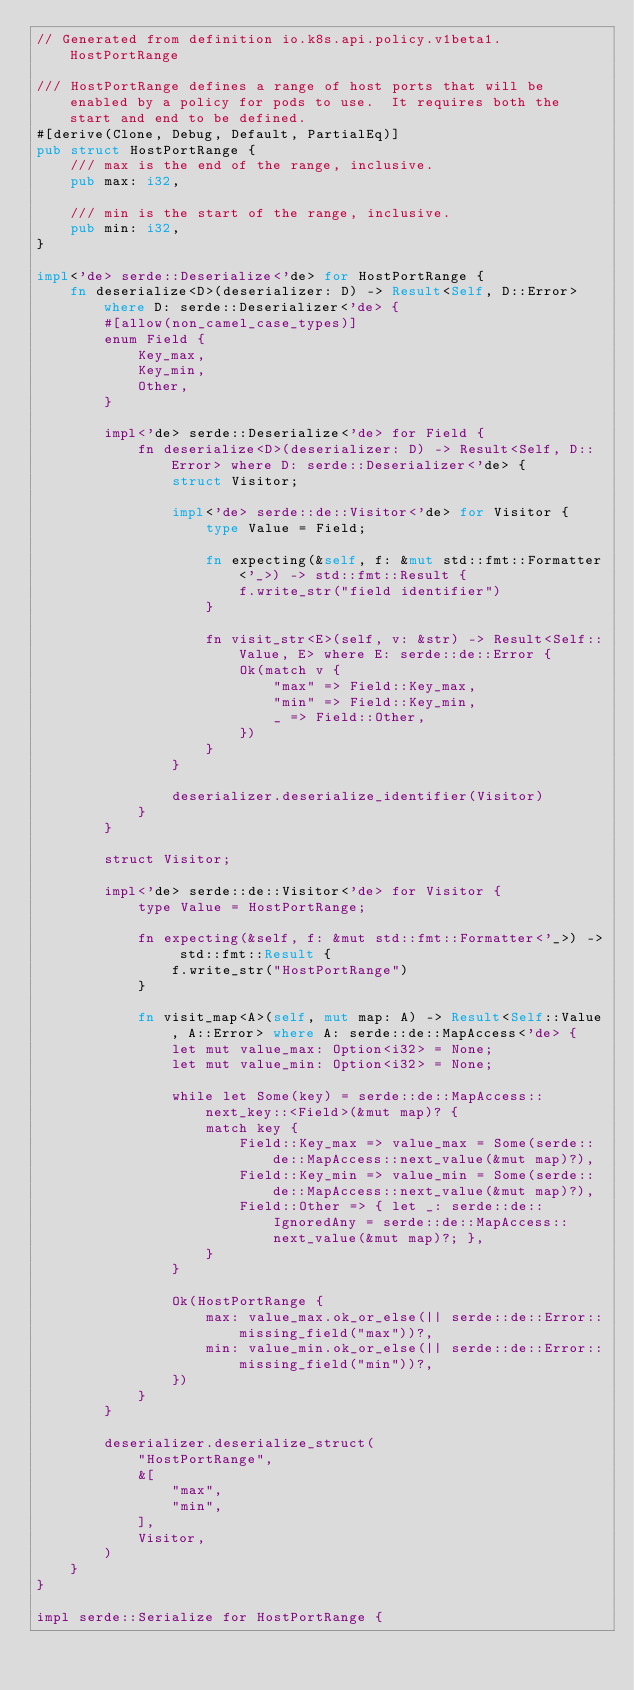Convert code to text. <code><loc_0><loc_0><loc_500><loc_500><_Rust_>// Generated from definition io.k8s.api.policy.v1beta1.HostPortRange

/// HostPortRange defines a range of host ports that will be enabled by a policy for pods to use.  It requires both the start and end to be defined.
#[derive(Clone, Debug, Default, PartialEq)]
pub struct HostPortRange {
    /// max is the end of the range, inclusive.
    pub max: i32,

    /// min is the start of the range, inclusive.
    pub min: i32,
}

impl<'de> serde::Deserialize<'de> for HostPortRange {
    fn deserialize<D>(deserializer: D) -> Result<Self, D::Error> where D: serde::Deserializer<'de> {
        #[allow(non_camel_case_types)]
        enum Field {
            Key_max,
            Key_min,
            Other,
        }

        impl<'de> serde::Deserialize<'de> for Field {
            fn deserialize<D>(deserializer: D) -> Result<Self, D::Error> where D: serde::Deserializer<'de> {
                struct Visitor;

                impl<'de> serde::de::Visitor<'de> for Visitor {
                    type Value = Field;

                    fn expecting(&self, f: &mut std::fmt::Formatter<'_>) -> std::fmt::Result {
                        f.write_str("field identifier")
                    }

                    fn visit_str<E>(self, v: &str) -> Result<Self::Value, E> where E: serde::de::Error {
                        Ok(match v {
                            "max" => Field::Key_max,
                            "min" => Field::Key_min,
                            _ => Field::Other,
                        })
                    }
                }

                deserializer.deserialize_identifier(Visitor)
            }
        }

        struct Visitor;

        impl<'de> serde::de::Visitor<'de> for Visitor {
            type Value = HostPortRange;

            fn expecting(&self, f: &mut std::fmt::Formatter<'_>) -> std::fmt::Result {
                f.write_str("HostPortRange")
            }

            fn visit_map<A>(self, mut map: A) -> Result<Self::Value, A::Error> where A: serde::de::MapAccess<'de> {
                let mut value_max: Option<i32> = None;
                let mut value_min: Option<i32> = None;

                while let Some(key) = serde::de::MapAccess::next_key::<Field>(&mut map)? {
                    match key {
                        Field::Key_max => value_max = Some(serde::de::MapAccess::next_value(&mut map)?),
                        Field::Key_min => value_min = Some(serde::de::MapAccess::next_value(&mut map)?),
                        Field::Other => { let _: serde::de::IgnoredAny = serde::de::MapAccess::next_value(&mut map)?; },
                    }
                }

                Ok(HostPortRange {
                    max: value_max.ok_or_else(|| serde::de::Error::missing_field("max"))?,
                    min: value_min.ok_or_else(|| serde::de::Error::missing_field("min"))?,
                })
            }
        }

        deserializer.deserialize_struct(
            "HostPortRange",
            &[
                "max",
                "min",
            ],
            Visitor,
        )
    }
}

impl serde::Serialize for HostPortRange {</code> 